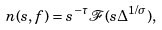Convert formula to latex. <formula><loc_0><loc_0><loc_500><loc_500>n ( s , f ) = s ^ { - \tau } \mathcal { F } ( s \Delta ^ { 1 / \sigma } ) ,</formula> 